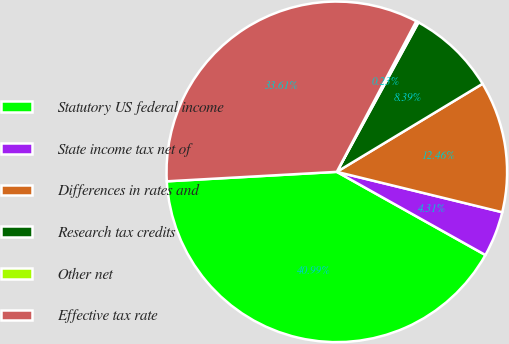Convert chart. <chart><loc_0><loc_0><loc_500><loc_500><pie_chart><fcel>Statutory US federal income<fcel>State income tax net of<fcel>Differences in rates and<fcel>Research tax credits<fcel>Other net<fcel>Effective tax rate<nl><fcel>40.99%<fcel>4.31%<fcel>12.46%<fcel>8.39%<fcel>0.23%<fcel>33.61%<nl></chart> 